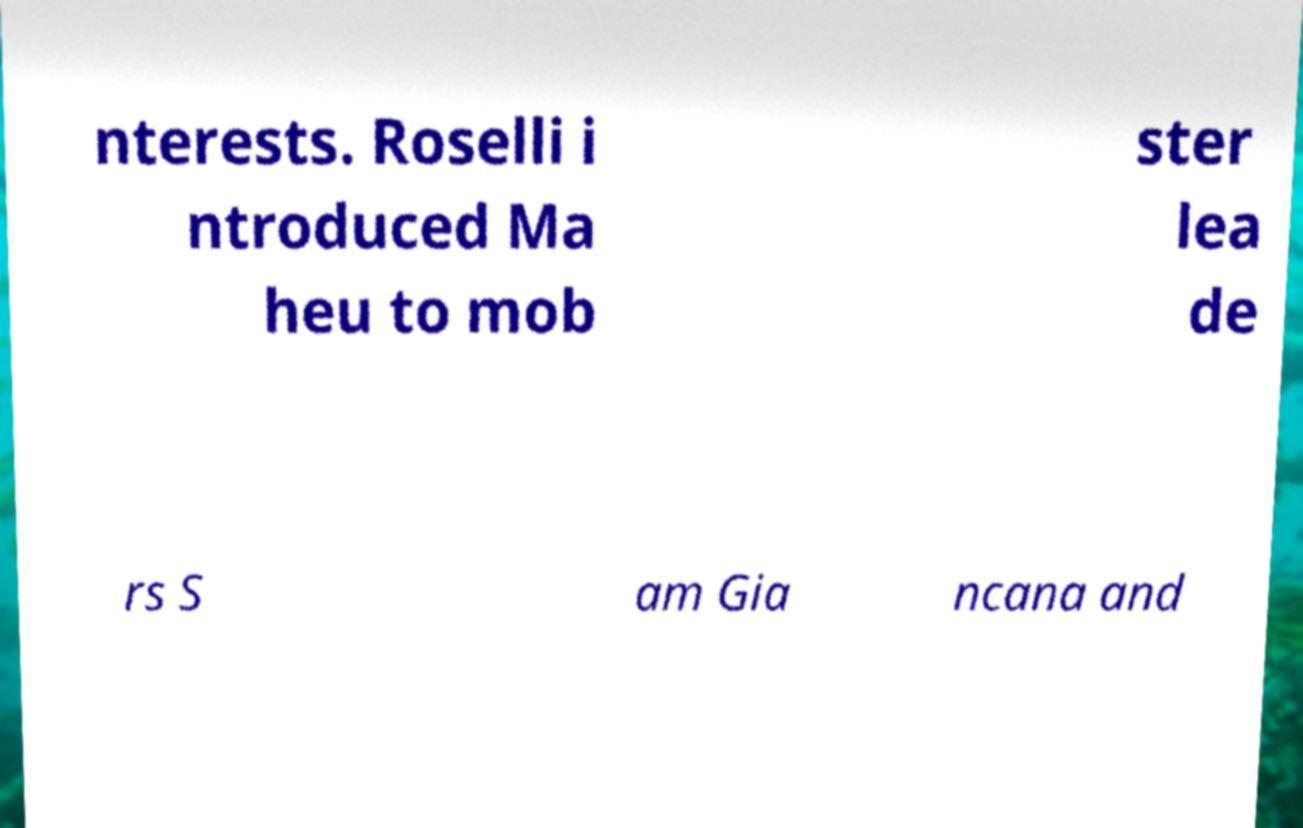Could you extract and type out the text from this image? nterests. Roselli i ntroduced Ma heu to mob ster lea de rs S am Gia ncana and 